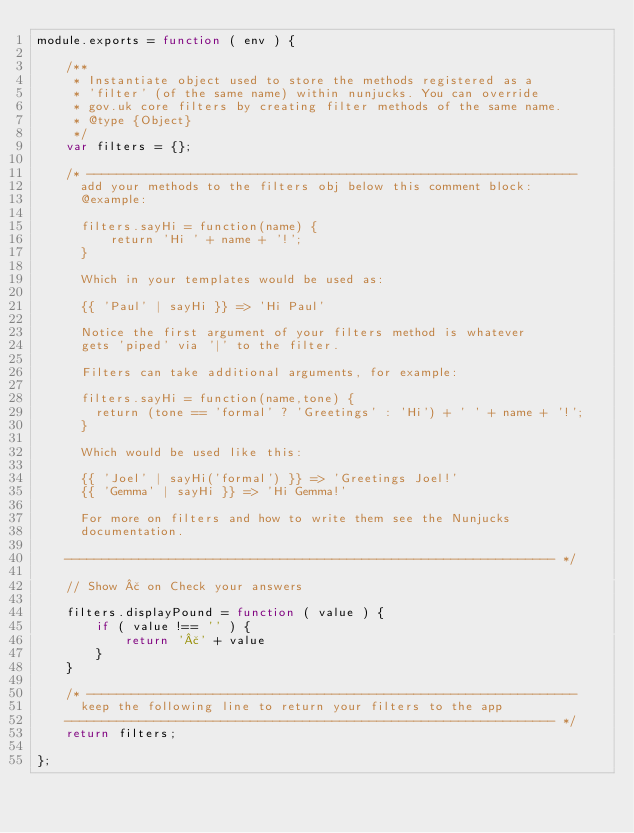<code> <loc_0><loc_0><loc_500><loc_500><_JavaScript_>module.exports = function ( env ) {

	/**
	 * Instantiate object used to store the methods registered as a
	 * 'filter' (of the same name) within nunjucks. You can override
	 * gov.uk core filters by creating filter methods of the same name.
	 * @type {Object}
	 */
	var filters = {};

	/* ------------------------------------------------------------------
	  add your methods to the filters obj below this comment block:
	  @example:

	  filters.sayHi = function(name) {
	      return 'Hi ' + name + '!';
	  }

	  Which in your templates would be used as:

	  {{ 'Paul' | sayHi }} => 'Hi Paul'

	  Notice the first argument of your filters method is whatever
	  gets 'piped' via '|' to the filter.

	  Filters can take additional arguments, for example:

	  filters.sayHi = function(name,tone) {
	    return (tone == 'formal' ? 'Greetings' : 'Hi') + ' ' + name + '!';
	  }

	  Which would be used like this:

	  {{ 'Joel' | sayHi('formal') }} => 'Greetings Joel!'
	  {{ 'Gemma' | sayHi }} => 'Hi Gemma!'

	  For more on filters and how to write them see the Nunjucks
	  documentation.

	------------------------------------------------------------------ */

	// Show £ on Check your answers

	filters.displayPound = function ( value ) {
		if ( value !== '' ) {
			return '£' + value
		}
	}

	/* ------------------------------------------------------------------
	  keep the following line to return your filters to the app
	------------------------------------------------------------------ */
	return filters;

};</code> 